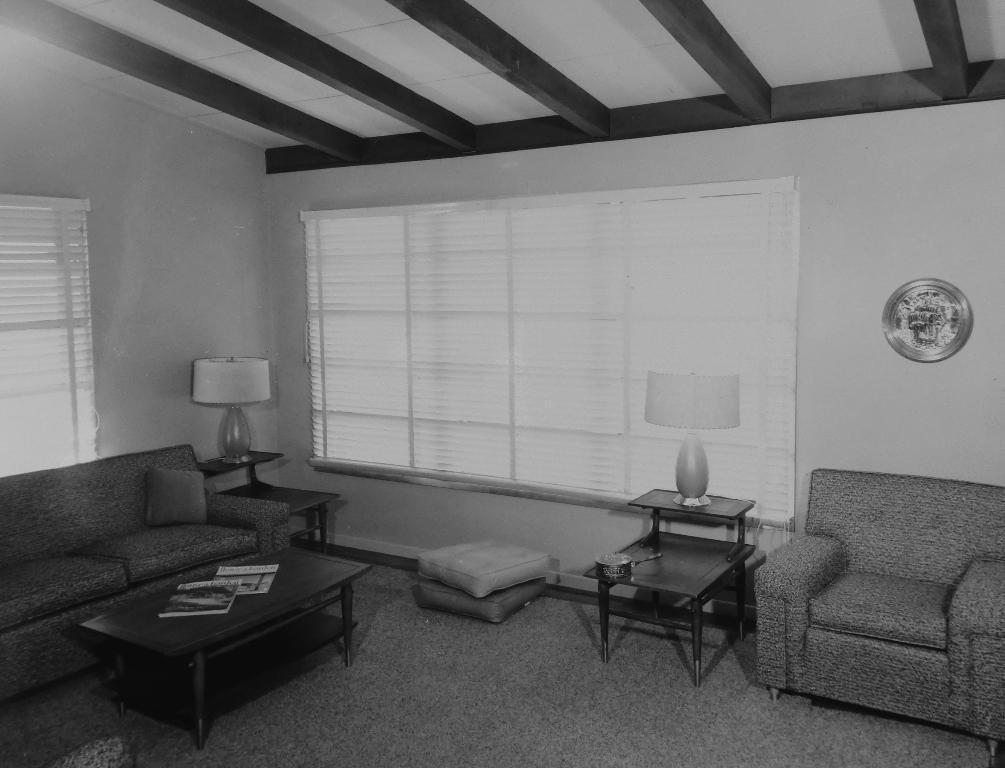Please provide a concise description of this image. In this image I can see a couch,pillow and a table. On the right side there is a chair. On the table there are books and a lamp. At the back side there is a window and a wall. 